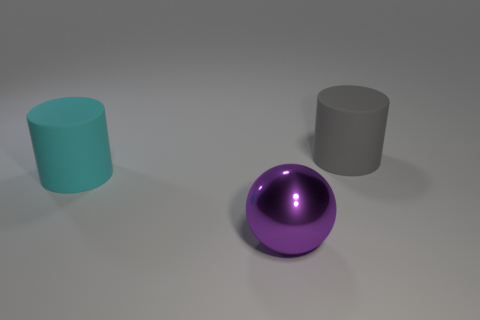There is a rubber cylinder that is to the right of the purple sphere; does it have the same size as the large metallic ball?
Offer a very short reply. Yes. There is a big gray object that is the same shape as the cyan thing; what material is it?
Offer a very short reply. Rubber. Is the purple metallic object the same shape as the large gray matte object?
Offer a very short reply. No. There is a cylinder that is on the left side of the gray thing; how many big gray matte things are on the left side of it?
Ensure brevity in your answer.  0. What shape is the cyan object that is made of the same material as the large gray cylinder?
Keep it short and to the point. Cylinder. How many purple things are either large objects or shiny things?
Make the answer very short. 1. There is a big matte object on the left side of the object that is behind the cyan object; is there a big cyan matte cylinder that is in front of it?
Your answer should be very brief. No. Are there fewer large matte cylinders than cyan rubber objects?
Ensure brevity in your answer.  No. There is a large object behind the big cyan matte cylinder; is it the same shape as the large purple metallic object?
Give a very brief answer. No. Are any tiny purple blocks visible?
Give a very brief answer. No. 